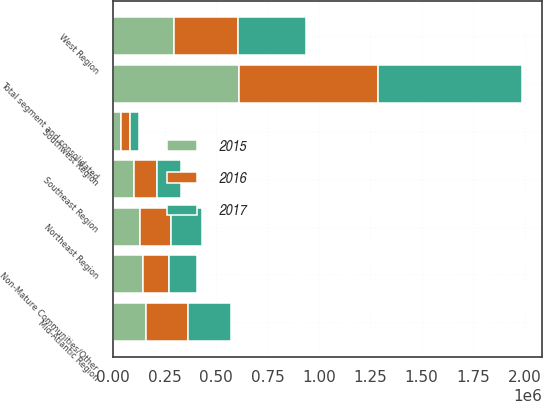<chart> <loc_0><loc_0><loc_500><loc_500><stacked_bar_chart><ecel><fcel>West Region<fcel>Mid-Atlantic Region<fcel>Northeast Region<fcel>Southeast Region<fcel>Southwest Region<fcel>Non-Mature Communities/Other<fcel>Total segment and consolidated<nl><fcel>2017<fcel>329322<fcel>209548<fcel>151736<fcel>116467<fcel>42992<fcel>134244<fcel>698503<nl><fcel>2016<fcel>315390<fcel>204408<fcel>147573<fcel>111318<fcel>41273<fcel>128499<fcel>673085<nl><fcel>2015<fcel>294048<fcel>158063<fcel>132079<fcel>103920<fcel>39166<fcel>144652<fcel>613869<nl></chart> 